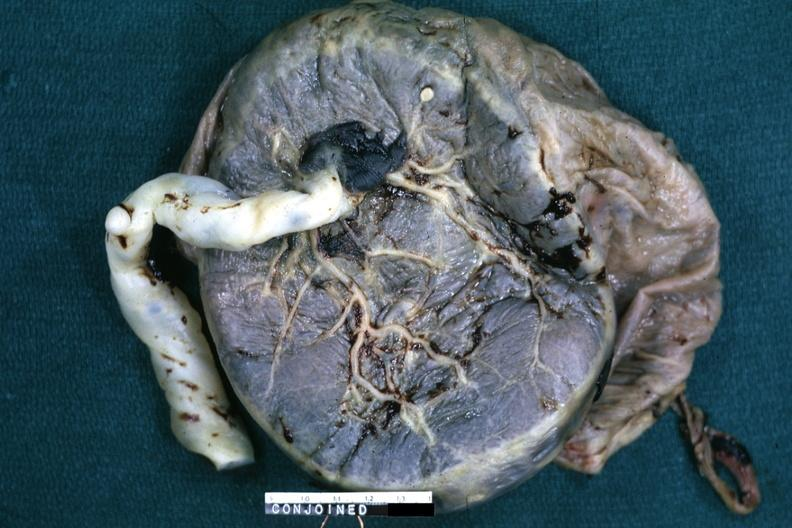s electron micrographs demonstrating fiber present?
Answer the question using a single word or phrase. No 